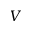<formula> <loc_0><loc_0><loc_500><loc_500>V</formula> 